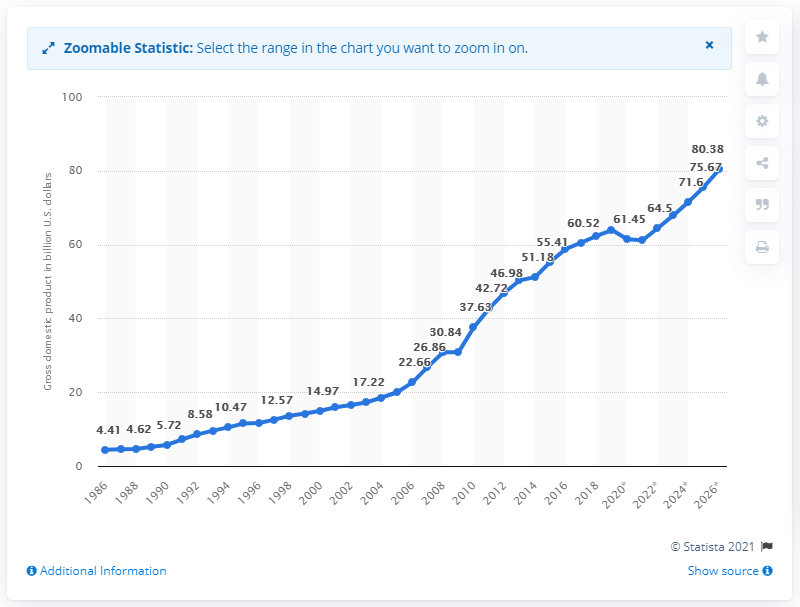Identify some key points in this picture. In 2019, the gross domestic product of Costa Rica was 64.5. 